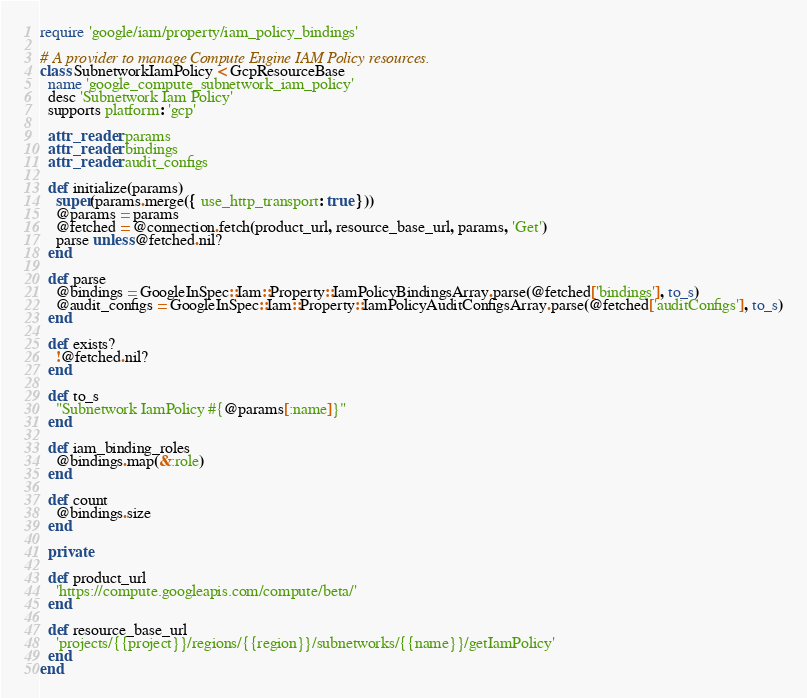Convert code to text. <code><loc_0><loc_0><loc_500><loc_500><_Ruby_>require 'google/iam/property/iam_policy_bindings'

# A provider to manage Compute Engine IAM Policy resources.
class SubnetworkIamPolicy < GcpResourceBase
  name 'google_compute_subnetwork_iam_policy'
  desc 'Subnetwork Iam Policy'
  supports platform: 'gcp'

  attr_reader :params
  attr_reader :bindings
  attr_reader :audit_configs

  def initialize(params)
    super(params.merge({ use_http_transport: true }))
    @params = params
    @fetched = @connection.fetch(product_url, resource_base_url, params, 'Get')
    parse unless @fetched.nil?
  end

  def parse
    @bindings = GoogleInSpec::Iam::Property::IamPolicyBindingsArray.parse(@fetched['bindings'], to_s)
    @audit_configs = GoogleInSpec::Iam::Property::IamPolicyAuditConfigsArray.parse(@fetched['auditConfigs'], to_s)
  end

  def exists?
    !@fetched.nil?
  end

  def to_s
    "Subnetwork IamPolicy #{@params[:name]}"
  end

  def iam_binding_roles
    @bindings.map(&:role)
  end

  def count
    @bindings.size
  end

  private

  def product_url
    'https://compute.googleapis.com/compute/beta/'
  end

  def resource_base_url
    'projects/{{project}}/regions/{{region}}/subnetworks/{{name}}/getIamPolicy'
  end
end
</code> 